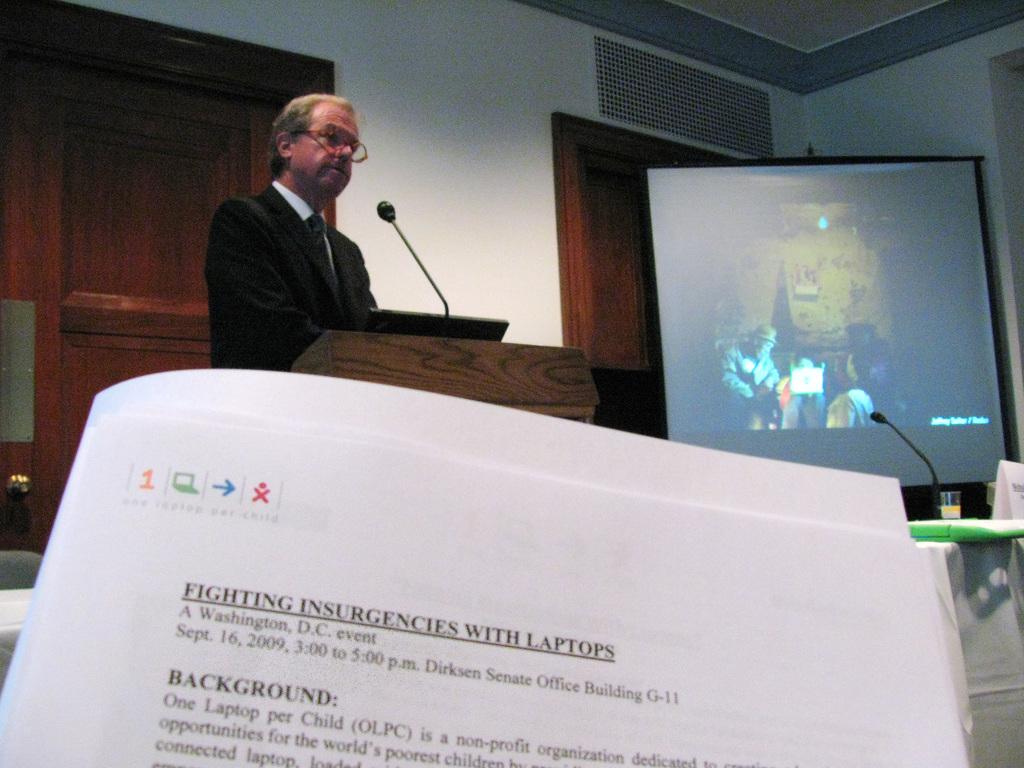What is mentioned as one per child?
Your answer should be compact. Laptop. What is the name of this event?
Your answer should be compact. Fighting insurgencies with laptops. 